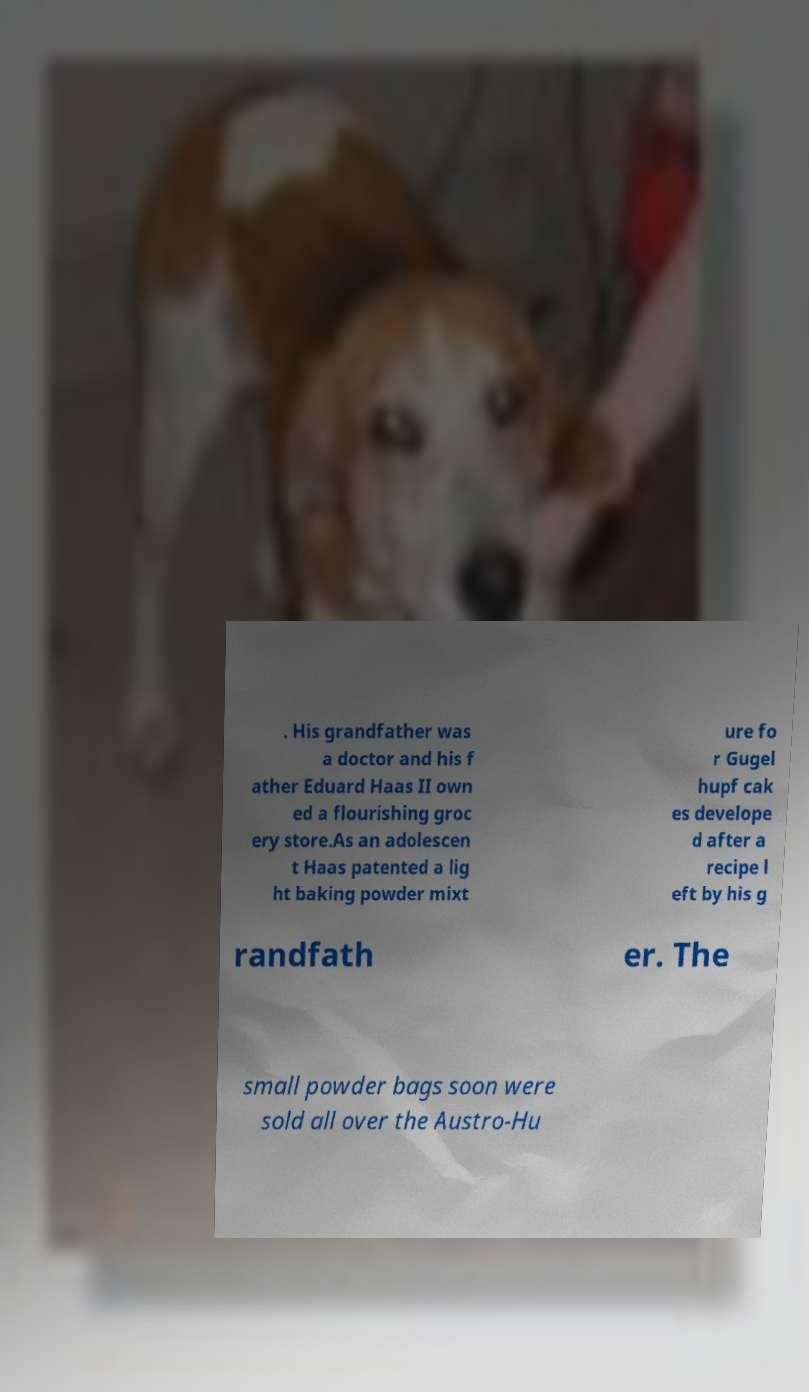Could you extract and type out the text from this image? . His grandfather was a doctor and his f ather Eduard Haas II own ed a flourishing groc ery store.As an adolescen t Haas patented a lig ht baking powder mixt ure fo r Gugel hupf cak es develope d after a recipe l eft by his g randfath er. The small powder bags soon were sold all over the Austro-Hu 